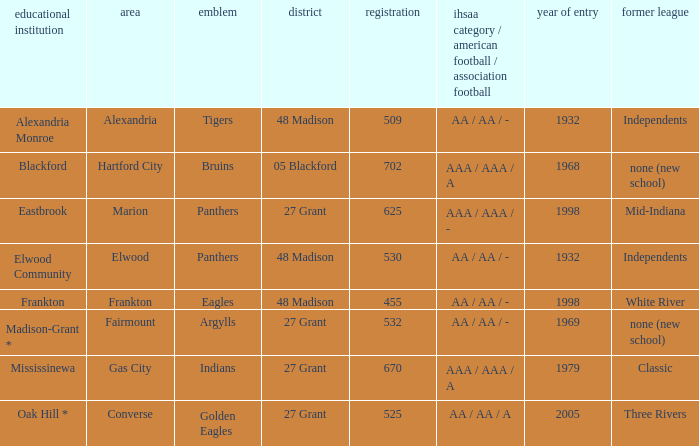What is the previous conference when the location is converse? Three Rivers. 